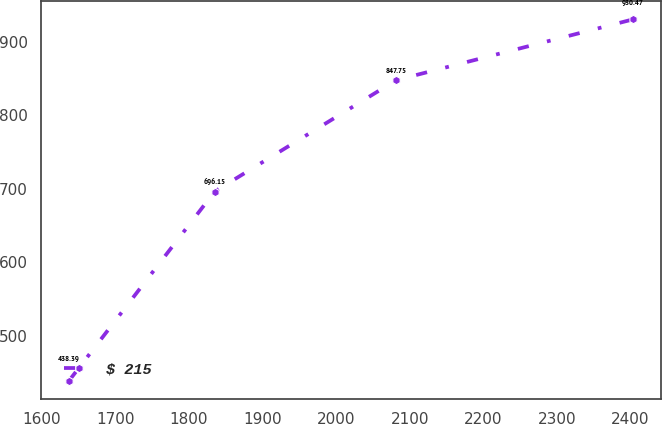Convert chart to OTSL. <chart><loc_0><loc_0><loc_500><loc_500><line_chart><ecel><fcel>$ 215<nl><fcel>1636.8<fcel>438.39<nl><fcel>1834.97<fcel>696.15<nl><fcel>2081.7<fcel>847.75<nl><fcel>2403.64<fcel>930.47<nl></chart> 